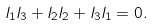<formula> <loc_0><loc_0><loc_500><loc_500>l _ { 1 } l _ { 3 } + l _ { 2 } l _ { 2 } + l _ { 3 } l _ { 1 } = 0 .</formula> 